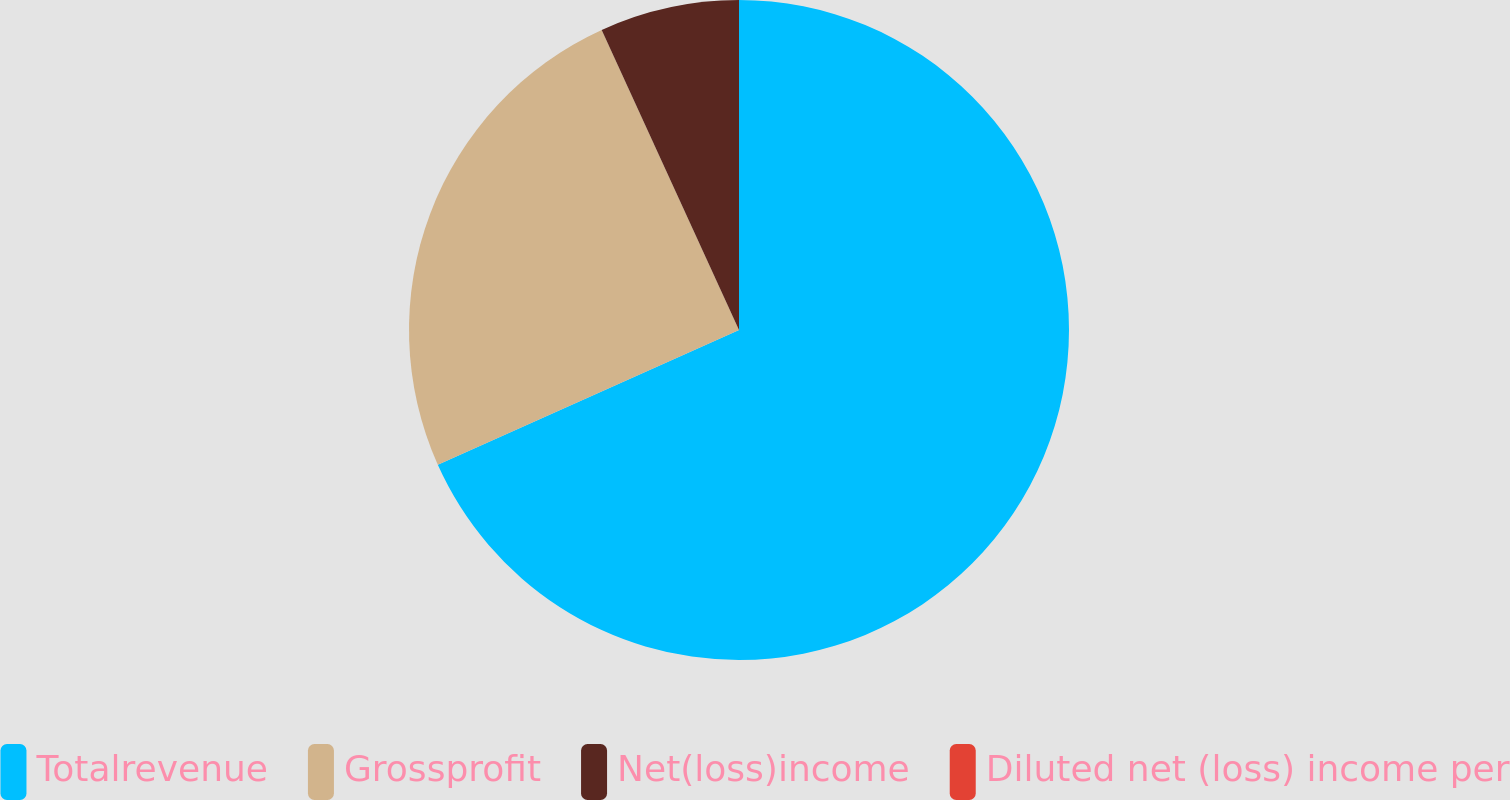<chart> <loc_0><loc_0><loc_500><loc_500><pie_chart><fcel>Totalrevenue<fcel>Grossprofit<fcel>Net(loss)income<fcel>Diluted net (loss) income per<nl><fcel>68.3%<fcel>24.87%<fcel>6.83%<fcel>0.0%<nl></chart> 